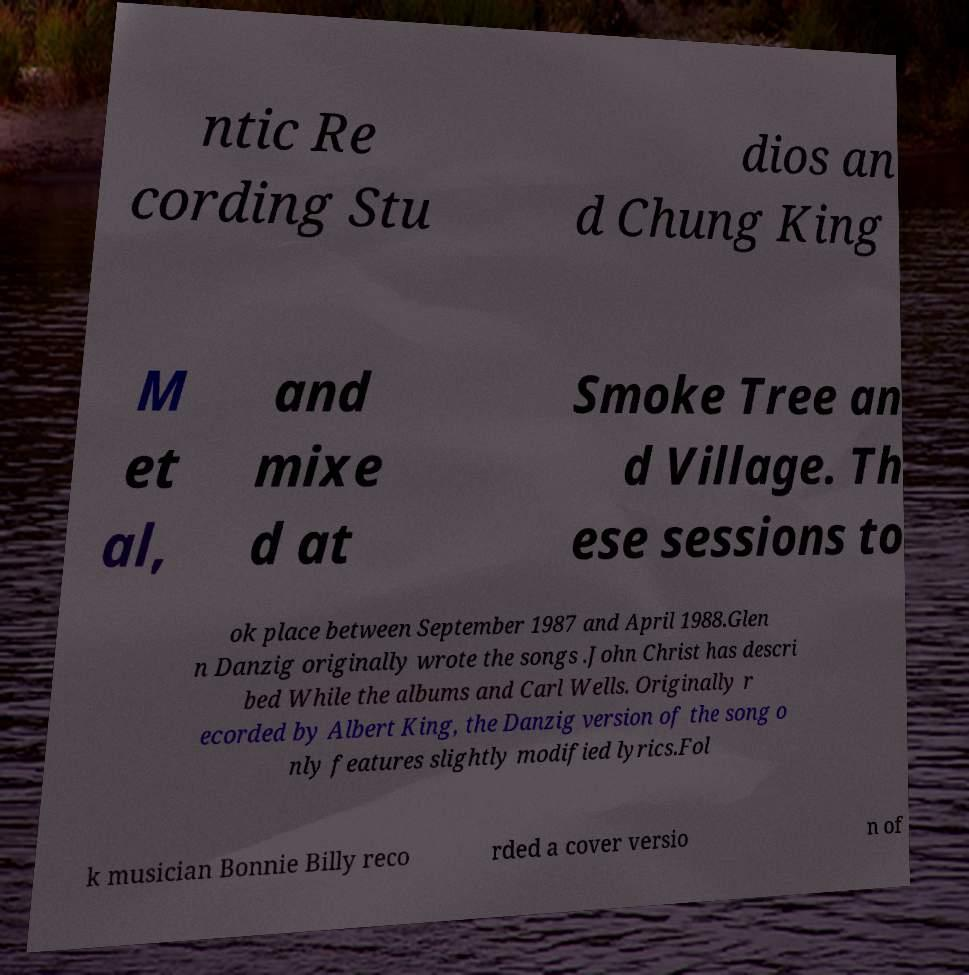Can you read and provide the text displayed in the image?This photo seems to have some interesting text. Can you extract and type it out for me? ntic Re cording Stu dios an d Chung King M et al, and mixe d at Smoke Tree an d Village. Th ese sessions to ok place between September 1987 and April 1988.Glen n Danzig originally wrote the songs .John Christ has descri bed While the albums and Carl Wells. Originally r ecorded by Albert King, the Danzig version of the song o nly features slightly modified lyrics.Fol k musician Bonnie Billy reco rded a cover versio n of 